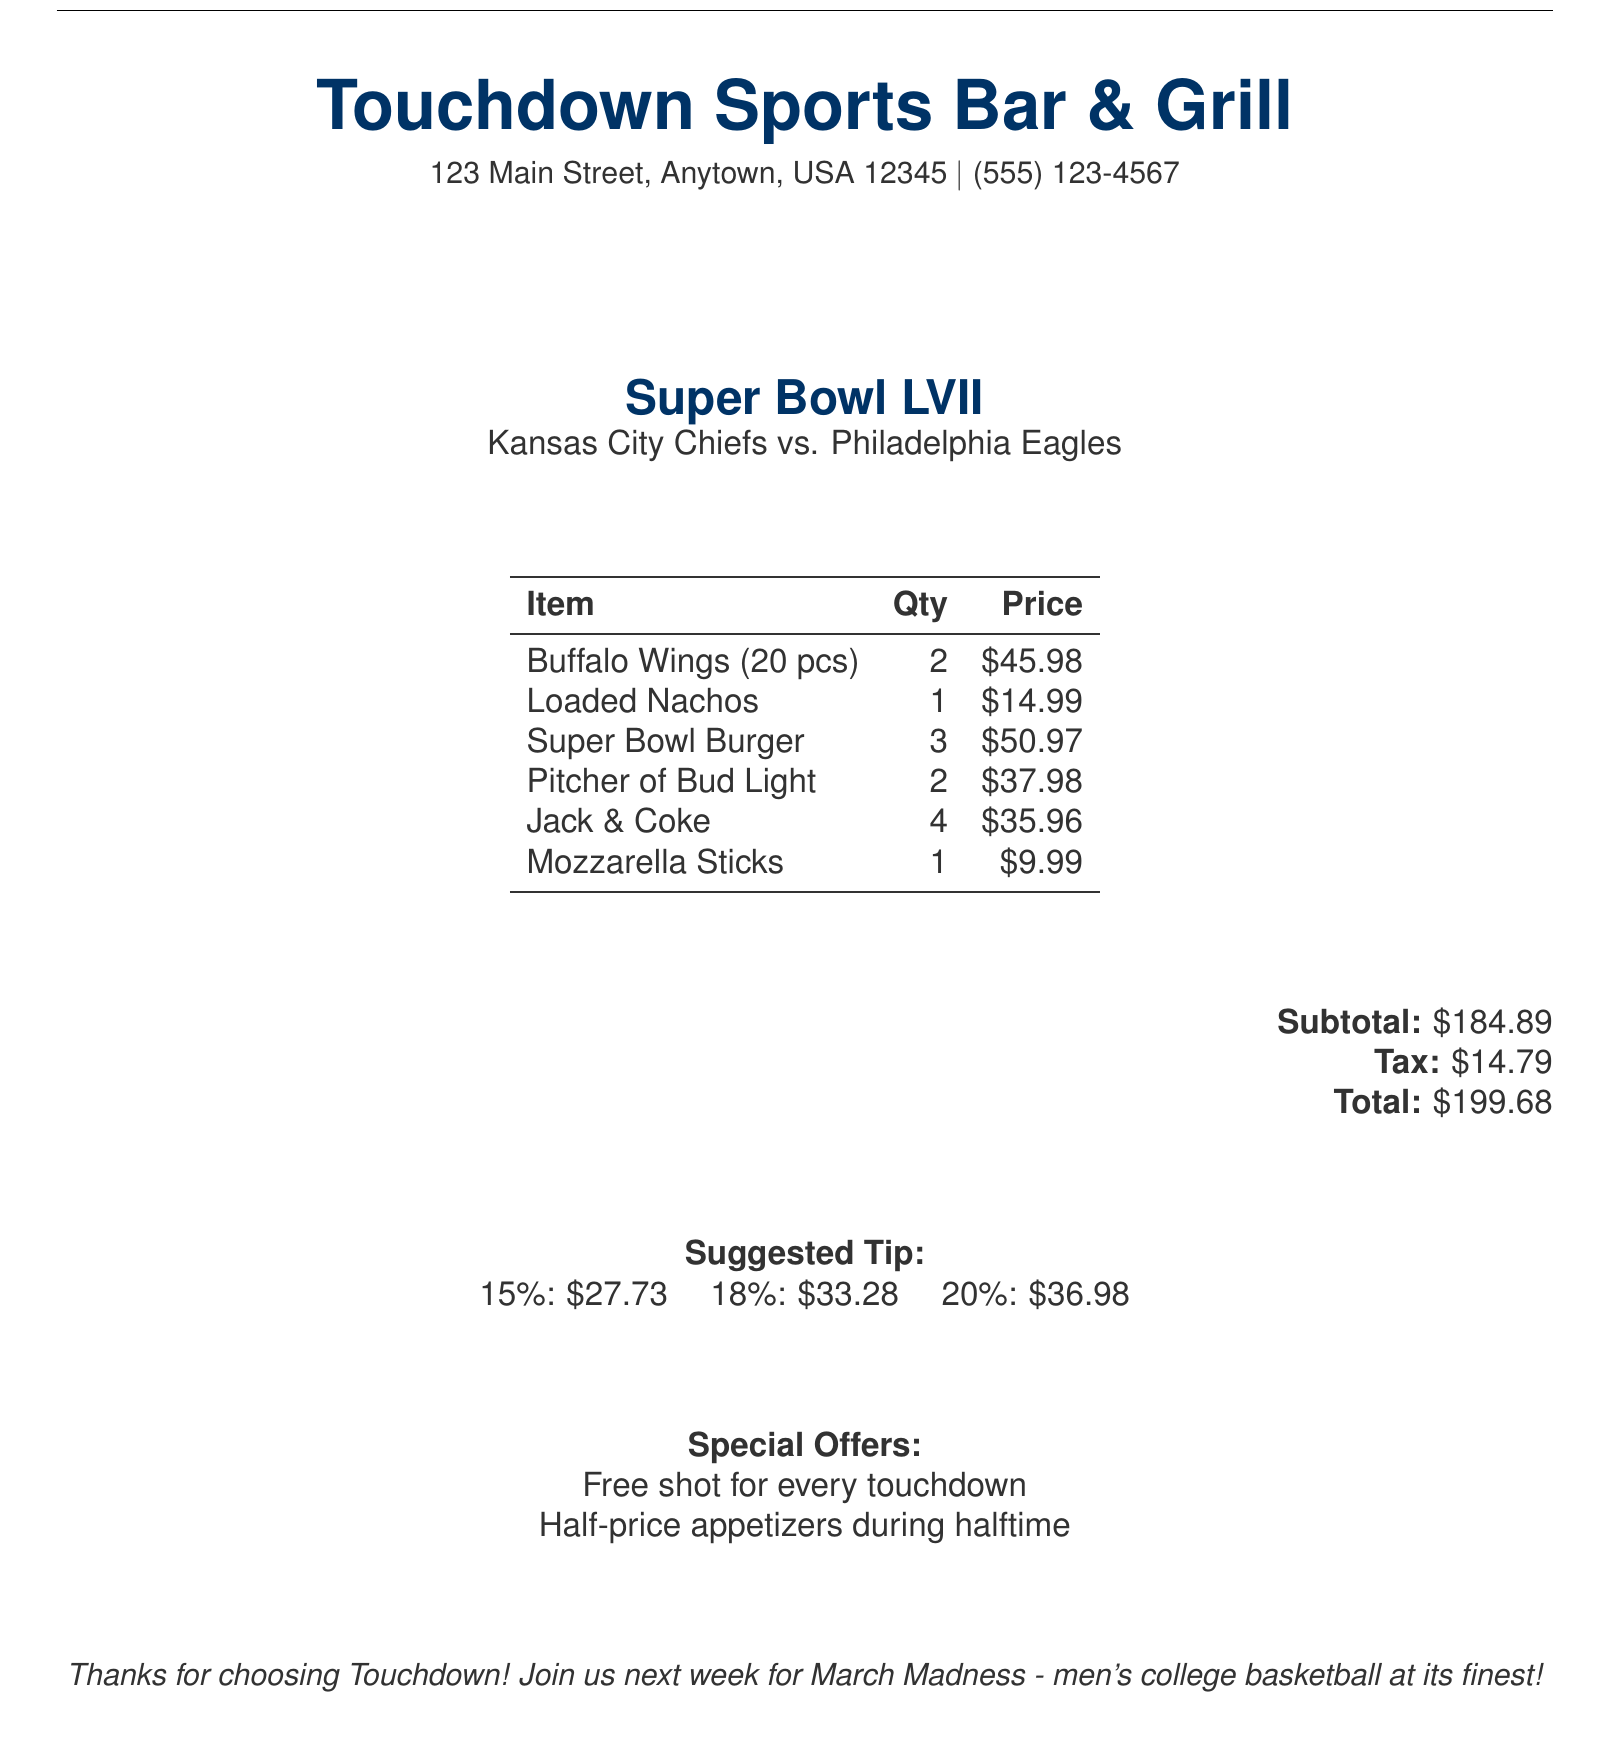What is the restaurant name? The restaurant name is mentioned at the top of the document, clearly stated.
Answer: Touchdown Sports Bar & Grill What date was the bill issued? The date of the bill is specified in the document's header.
Answer: February 12, 2023 Who was the server? The name of the server is provided in the document next to the date and time.
Answer: Mike What event was being celebrated? The event name is prominently displayed, indicating the occasion for the visit.
Answer: Super Bowl LVII What is the total amount on the bill? The total amount is listed at the bottom of the document under the totals section.
Answer: $199.68 How many Super Bowl Burgers were ordered? The quantity of Super Bowl Burgers can be found in the itemized list of food.
Answer: 3 What is suggested for a 20% tip? The tip suggestions are given in the section dedicated to tipping recommendations.
Answer: $36.98 Which teams were playing in the event? The teams playing are mentioned in the event name section of the document.
Answer: Kansas City Chiefs vs. Philadelphia Eagles What is the address of the restaurant? The address is provided beneath the restaurant name at the beginning of the document.
Answer: 123 Main Street, Anytown, USA 12345 